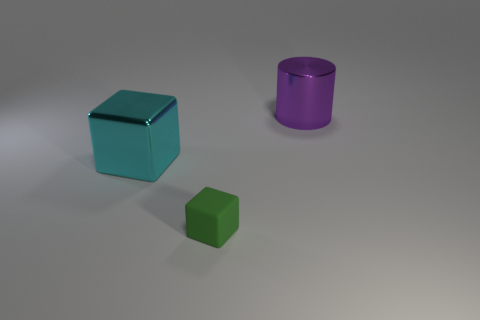Is there a cube that has the same material as the large purple thing?
Your answer should be compact. Yes. What is the material of the purple cylinder that is the same size as the metal block?
Keep it short and to the point. Metal. The green cube that is in front of the large object right of the small green matte object is made of what material?
Your response must be concise. Rubber. There is a large thing that is to the left of the rubber cube; is its shape the same as the purple thing?
Offer a terse response. No. What is the color of the object that is made of the same material as the big block?
Keep it short and to the point. Purple. There is a large thing right of the green cube; what is its material?
Provide a short and direct response. Metal. Is the shape of the big purple thing the same as the cyan object behind the green matte object?
Provide a succinct answer. No. There is a thing that is both on the right side of the cyan metal block and to the left of the big shiny cylinder; what material is it?
Provide a short and direct response. Rubber. What color is the cylinder that is the same size as the metallic block?
Your answer should be compact. Purple. Are the tiny thing and the thing that is on the left side of the small matte thing made of the same material?
Ensure brevity in your answer.  No. 